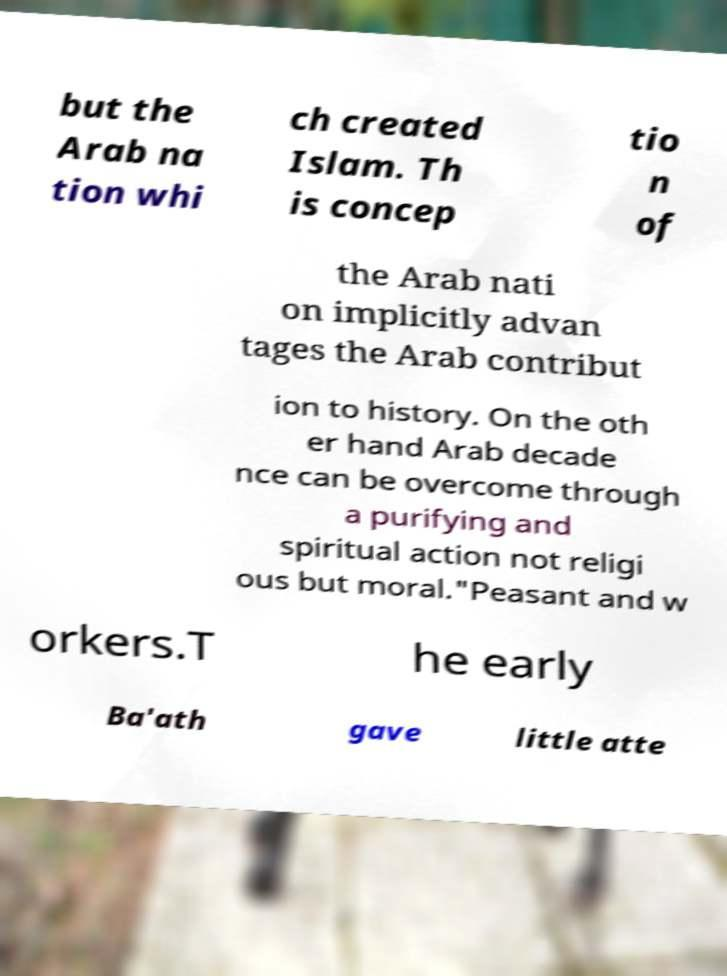There's text embedded in this image that I need extracted. Can you transcribe it verbatim? but the Arab na tion whi ch created Islam. Th is concep tio n of the Arab nati on implicitly advan tages the Arab contribut ion to history. On the oth er hand Arab decade nce can be overcome through a purifying and spiritual action not religi ous but moral."Peasant and w orkers.T he early Ba'ath gave little atte 